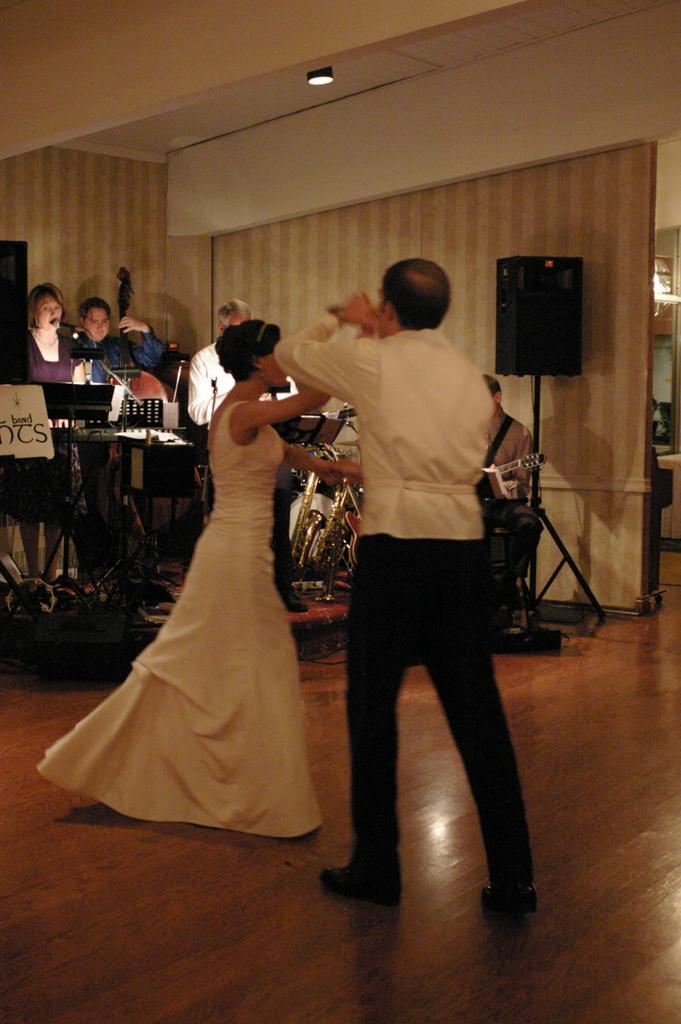What are the two persons in the image doing? The two persons in the image are dancing. What can be seen in the background of the image? There is a group of people in the background of the image. What objects are related to music in the image? Musical instruments and speakers with stands are present in the image. Can you tell me how many frogs are on the musical instruments in the image? There are no frogs present on the musical instruments or anywhere else in the image. What type of wheel is used to move the speakers in the image? There are no wheels visible in the image, and the speakers are not being moved. 